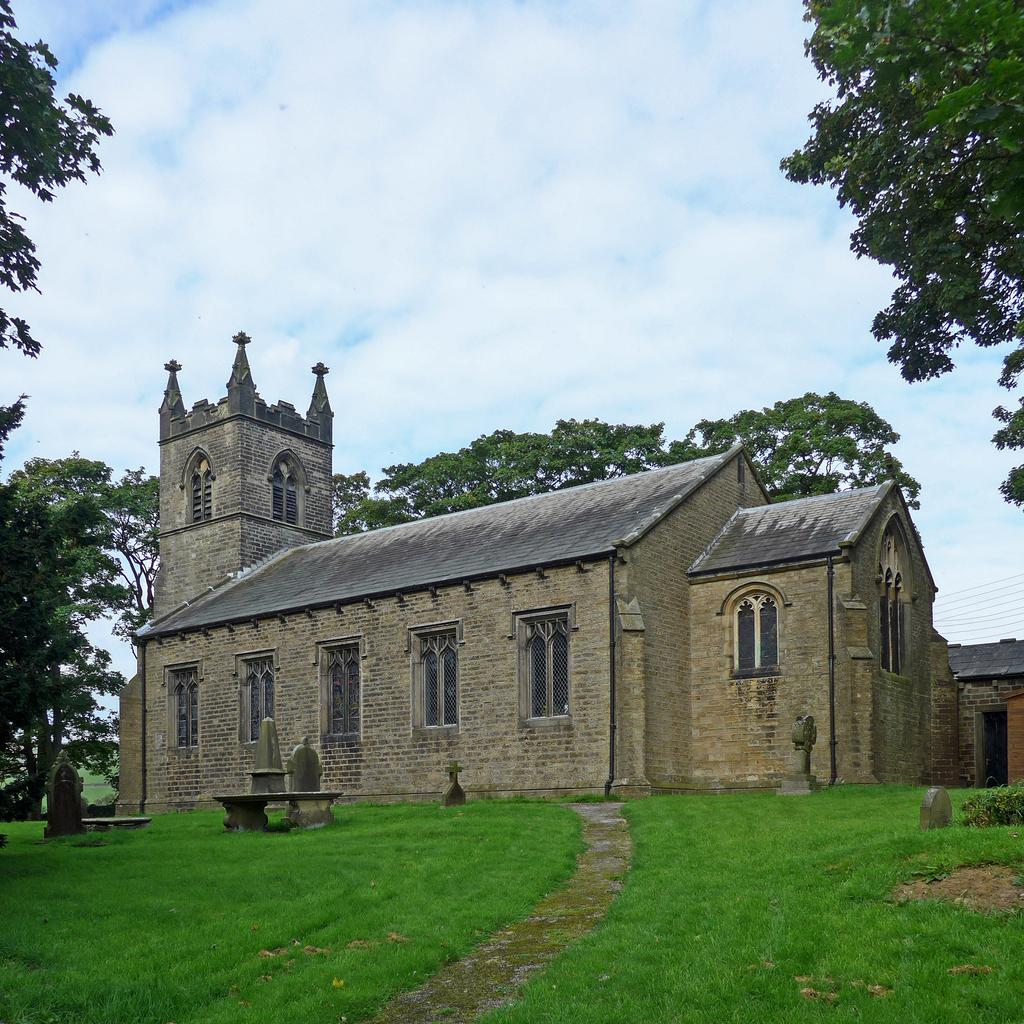What type of structure is present in the image? There is a building in the image. What type of vegetation can be seen in the image? There is grass in the image. What can be seen in the background of the image? There are trees in the background of the image. What is visible in the sky in the image? The sky is visible in the image. What objects are in front of the building? There are some objects in front of the building. What type of gun is being used by the potato in the image? There is no gun or potato present in the image. 